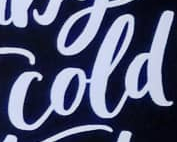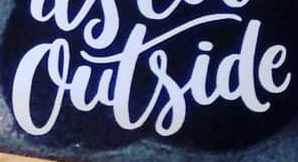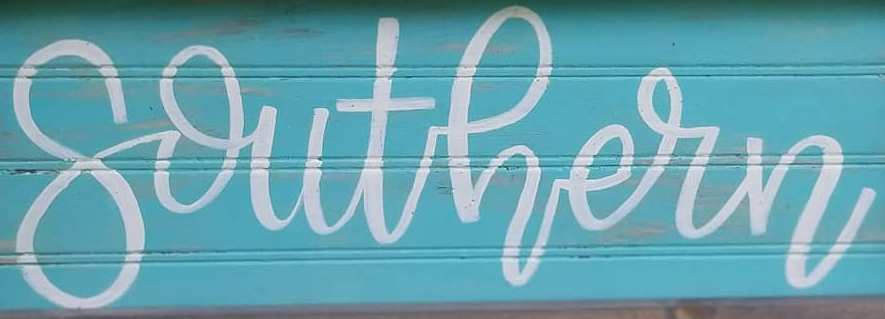What words are shown in these images in order, separated by a semicolon? cold; outside; southern 